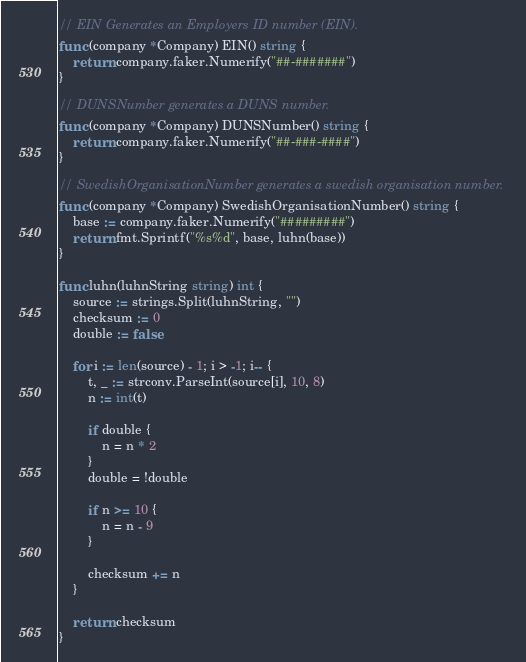<code> <loc_0><loc_0><loc_500><loc_500><_Go_>
// EIN Generates an Employers ID number (EIN).
func (company *Company) EIN() string {
	return company.faker.Numerify("##-#######")
}

// DUNSNumber generates a DUNS number.
func (company *Company) DUNSNumber() string {
	return company.faker.Numerify("##-###-####")
}

// SwedishOrganisationNumber generates a swedish organisation number.
func (company *Company) SwedishOrganisationNumber() string {
	base := company.faker.Numerify("#########")
	return fmt.Sprintf("%s%d", base, luhn(base))
}

func luhn(luhnString string) int {
	source := strings.Split(luhnString, "")
	checksum := 0
	double := false

	for i := len(source) - 1; i > -1; i-- {
		t, _ := strconv.ParseInt(source[i], 10, 8)
		n := int(t)

		if double {
			n = n * 2
		}
		double = !double

		if n >= 10 {
			n = n - 9
		}

		checksum += n
	}

	return checksum
}
</code> 